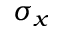Convert formula to latex. <formula><loc_0><loc_0><loc_500><loc_500>\sigma _ { x }</formula> 